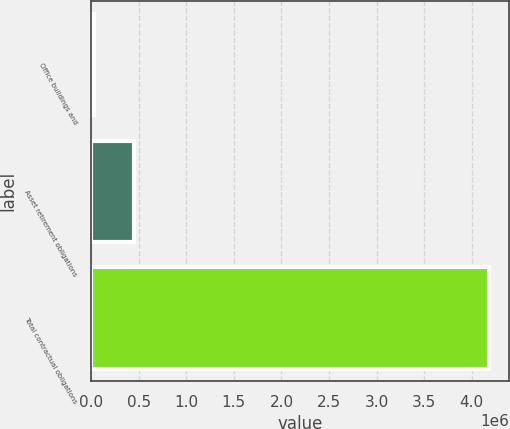Convert chart to OTSL. <chart><loc_0><loc_0><loc_500><loc_500><bar_chart><fcel>Office buildings and<fcel>Asset retirement obligations<fcel>Total contractual obligations<nl><fcel>32154<fcel>447431<fcel>4.18492e+06<nl></chart> 